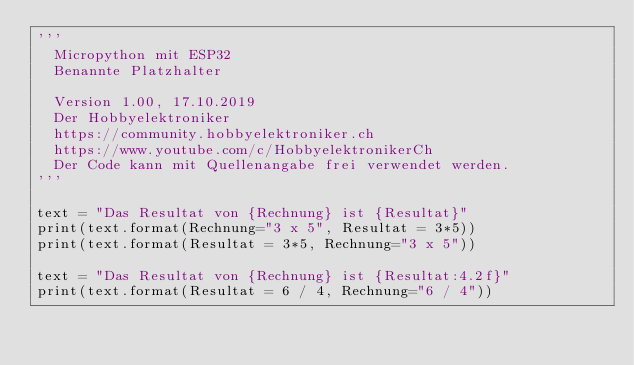<code> <loc_0><loc_0><loc_500><loc_500><_Python_>''' 
  Micropython mit ESP32
  Benannte Platzhalter
  
  Version 1.00, 17.10.2019
  Der Hobbyelektroniker
  https://community.hobbyelektroniker.ch
  https://www.youtube.com/c/HobbyelektronikerCh
  Der Code kann mit Quellenangabe frei verwendet werden.
'''

text = "Das Resultat von {Rechnung} ist {Resultat}"
print(text.format(Rechnung="3 x 5", Resultat = 3*5))
print(text.format(Resultat = 3*5, Rechnung="3 x 5"))

text = "Das Resultat von {Rechnung} ist {Resultat:4.2f}"
print(text.format(Resultat = 6 / 4, Rechnung="6 / 4"))

</code> 